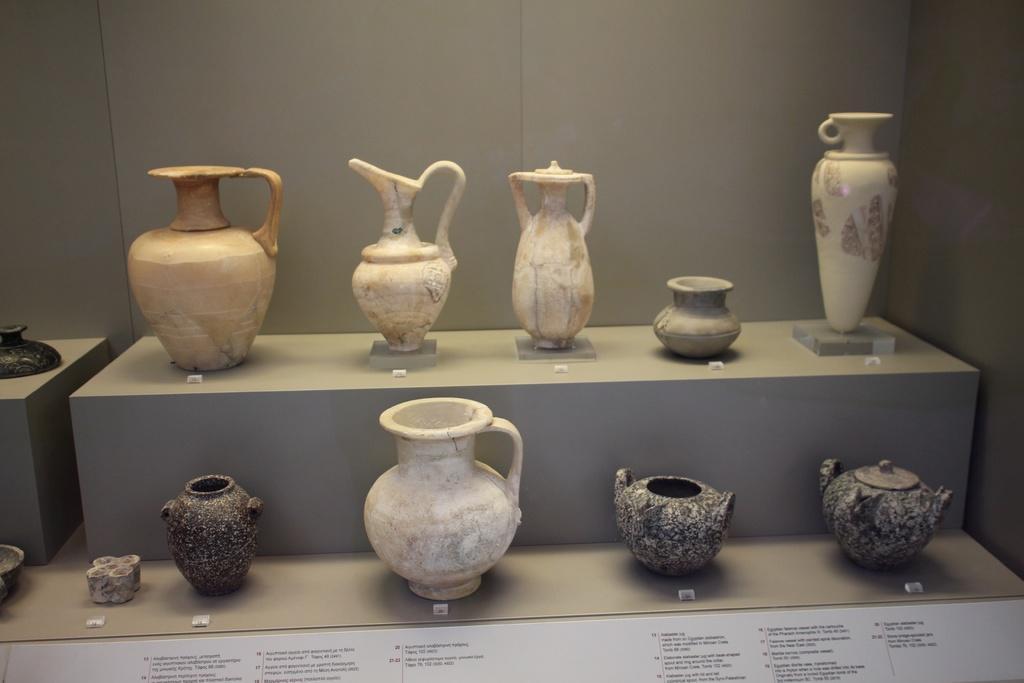Can you describe this image briefly? This image is taken indoors. In the background there is a wall. At the bottom of the image there is a board with a text on it. In the middle of the image there is a table with a few antique jugs and jars on it. 